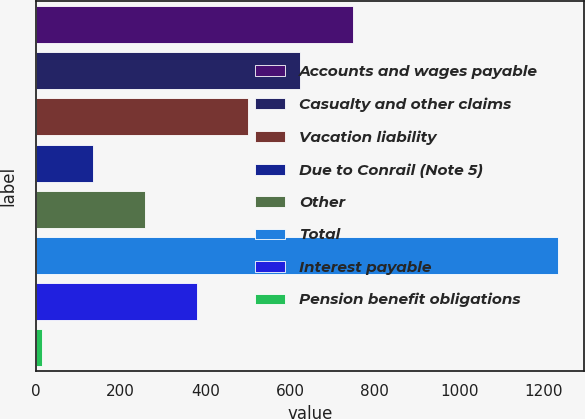Convert chart. <chart><loc_0><loc_0><loc_500><loc_500><bar_chart><fcel>Accounts and wages payable<fcel>Casualty and other claims<fcel>Vacation liability<fcel>Due to Conrail (Note 5)<fcel>Other<fcel>Total<fcel>Interest payable<fcel>Pension benefit obligations<nl><fcel>748<fcel>623.5<fcel>501.6<fcel>135.9<fcel>257.8<fcel>1233<fcel>379.7<fcel>14<nl></chart> 